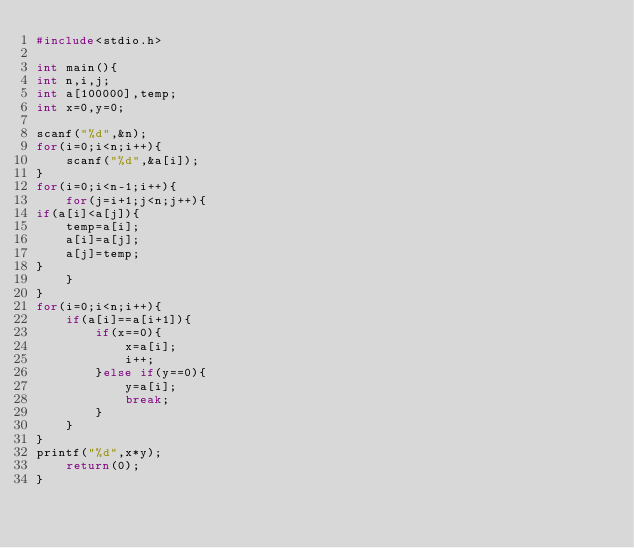<code> <loc_0><loc_0><loc_500><loc_500><_C_>#include<stdio.h>

int main(){
int n,i,j;
int a[100000],temp;
int x=0,y=0;

scanf("%d",&n);
for(i=0;i<n;i++){
    scanf("%d",&a[i]);
}
for(i=0;i<n-1;i++){
    for(j=i+1;j<n;j++){
if(a[i]<a[j]){
    temp=a[i];
    a[i]=a[j];
    a[j]=temp;
}
    }
}
for(i=0;i<n;i++){
    if(a[i]==a[i+1]){
        if(x==0){
            x=a[i];
            i++;
        }else if(y==0){
            y=a[i];
            break;
        }
    }
}
printf("%d",x*y);
    return(0);
}</code> 